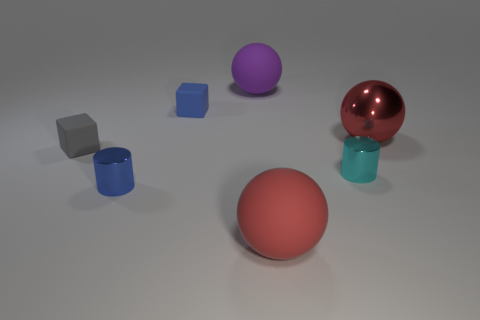Subtract all big red balls. How many balls are left? 1 Add 2 big green matte cubes. How many objects exist? 9 Subtract all brown cylinders. How many red spheres are left? 2 Subtract all purple balls. How many balls are left? 2 Subtract all cubes. How many objects are left? 5 Add 5 tiny brown spheres. How many tiny brown spheres exist? 5 Subtract 0 purple cylinders. How many objects are left? 7 Subtract 1 spheres. How many spheres are left? 2 Subtract all brown balls. Subtract all gray cubes. How many balls are left? 3 Subtract all gray matte objects. Subtract all gray rubber things. How many objects are left? 5 